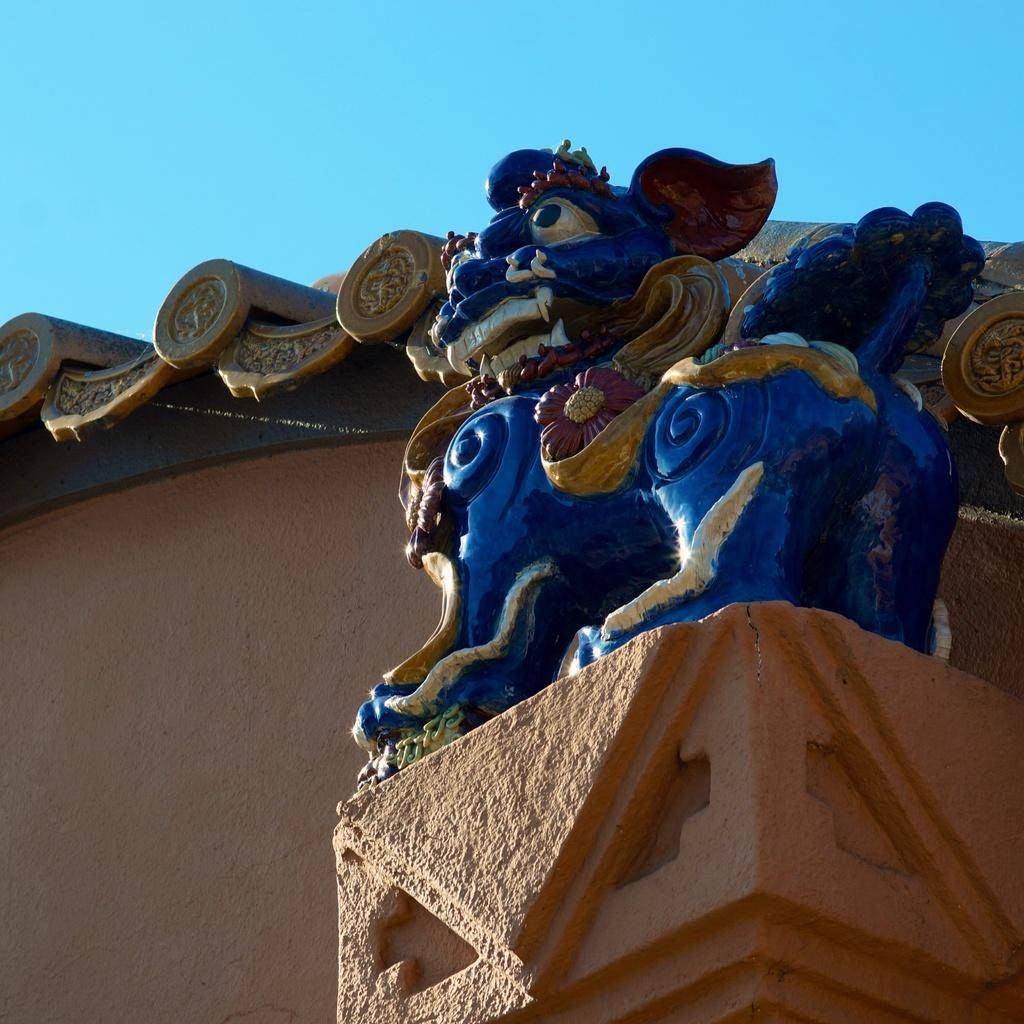What is located on top of the pillar in the image? There is a statue on a pillar in the image. What type of structure can be seen in the image? There is a wall visible in the image. What is visible in the background of the image? The sky is visible in the image. How many lizards can be seen climbing on the statue in the image? There are no lizards present in the image; it only features a statue on a pillar. What color is the orange that is being peeled in the image? There is no orange present in the image; it only features a statue on a pillar, a wall, and the sky. 